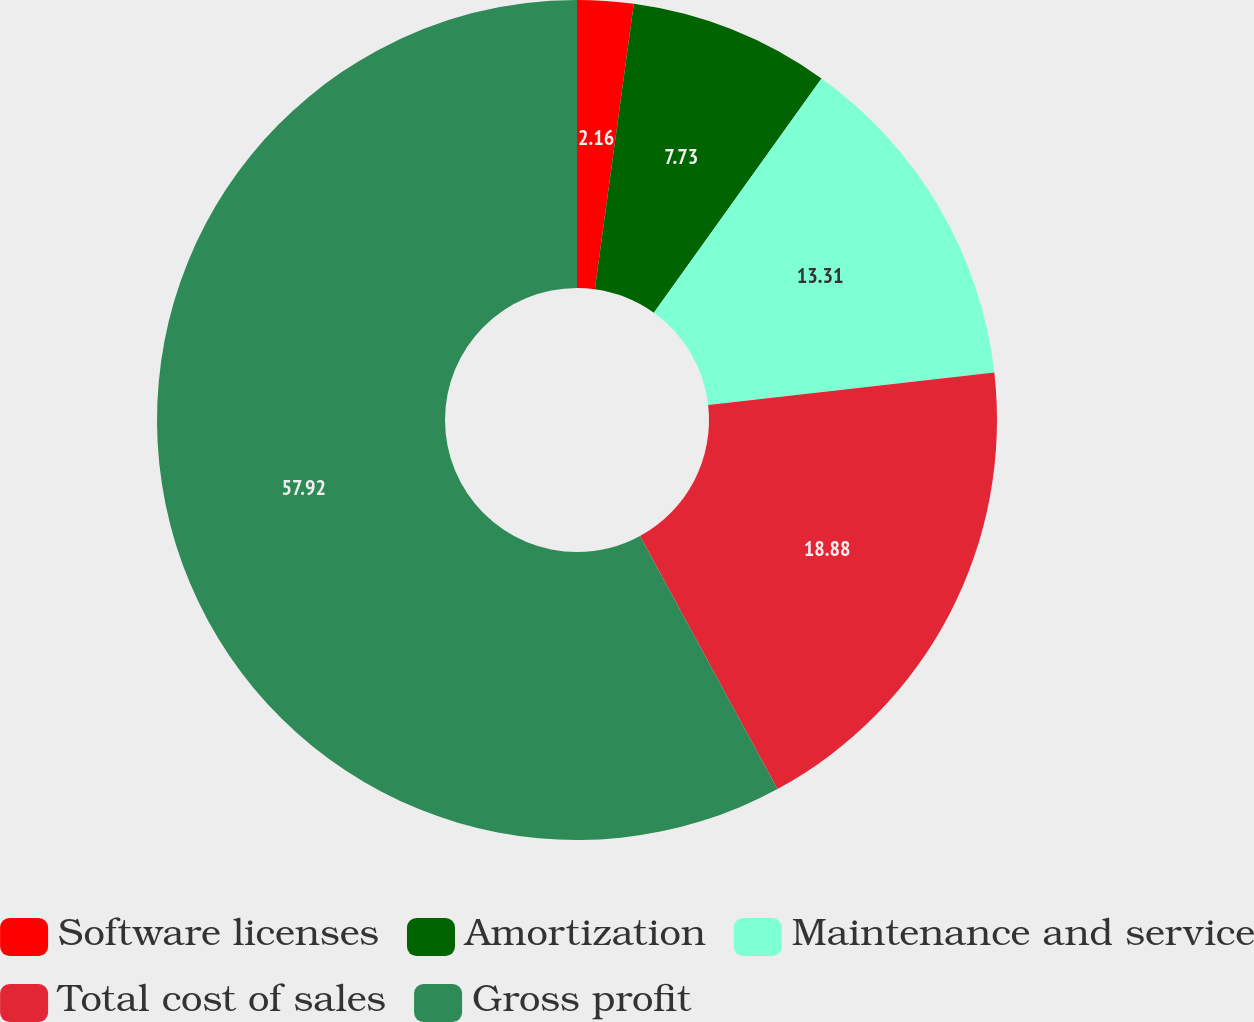<chart> <loc_0><loc_0><loc_500><loc_500><pie_chart><fcel>Software licenses<fcel>Amortization<fcel>Maintenance and service<fcel>Total cost of sales<fcel>Gross profit<nl><fcel>2.16%<fcel>7.73%<fcel>13.31%<fcel>18.88%<fcel>57.92%<nl></chart> 